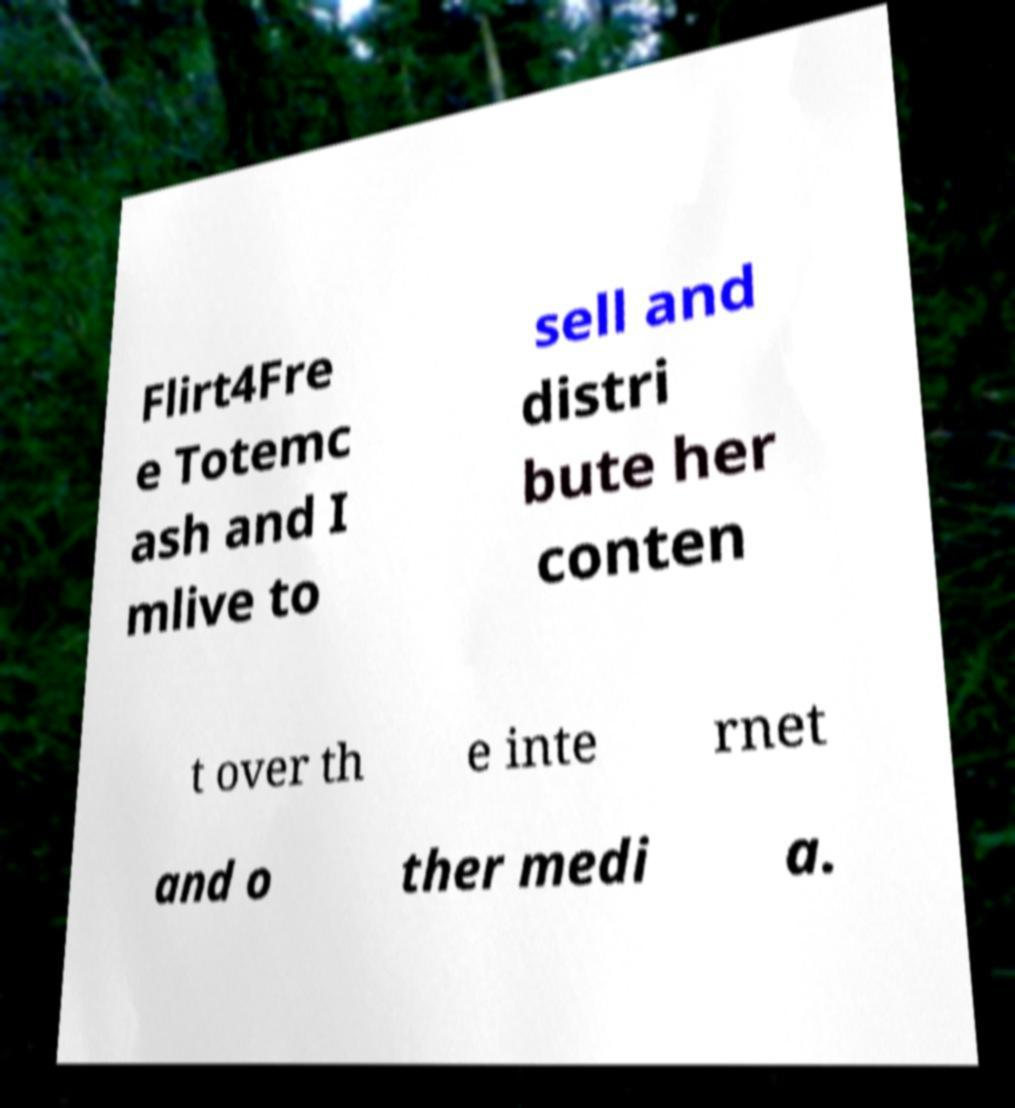Please identify and transcribe the text found in this image. Flirt4Fre e Totemc ash and I mlive to sell and distri bute her conten t over th e inte rnet and o ther medi a. 